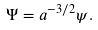<formula> <loc_0><loc_0><loc_500><loc_500>\Psi = a ^ { - 3 / 2 } \psi .</formula> 